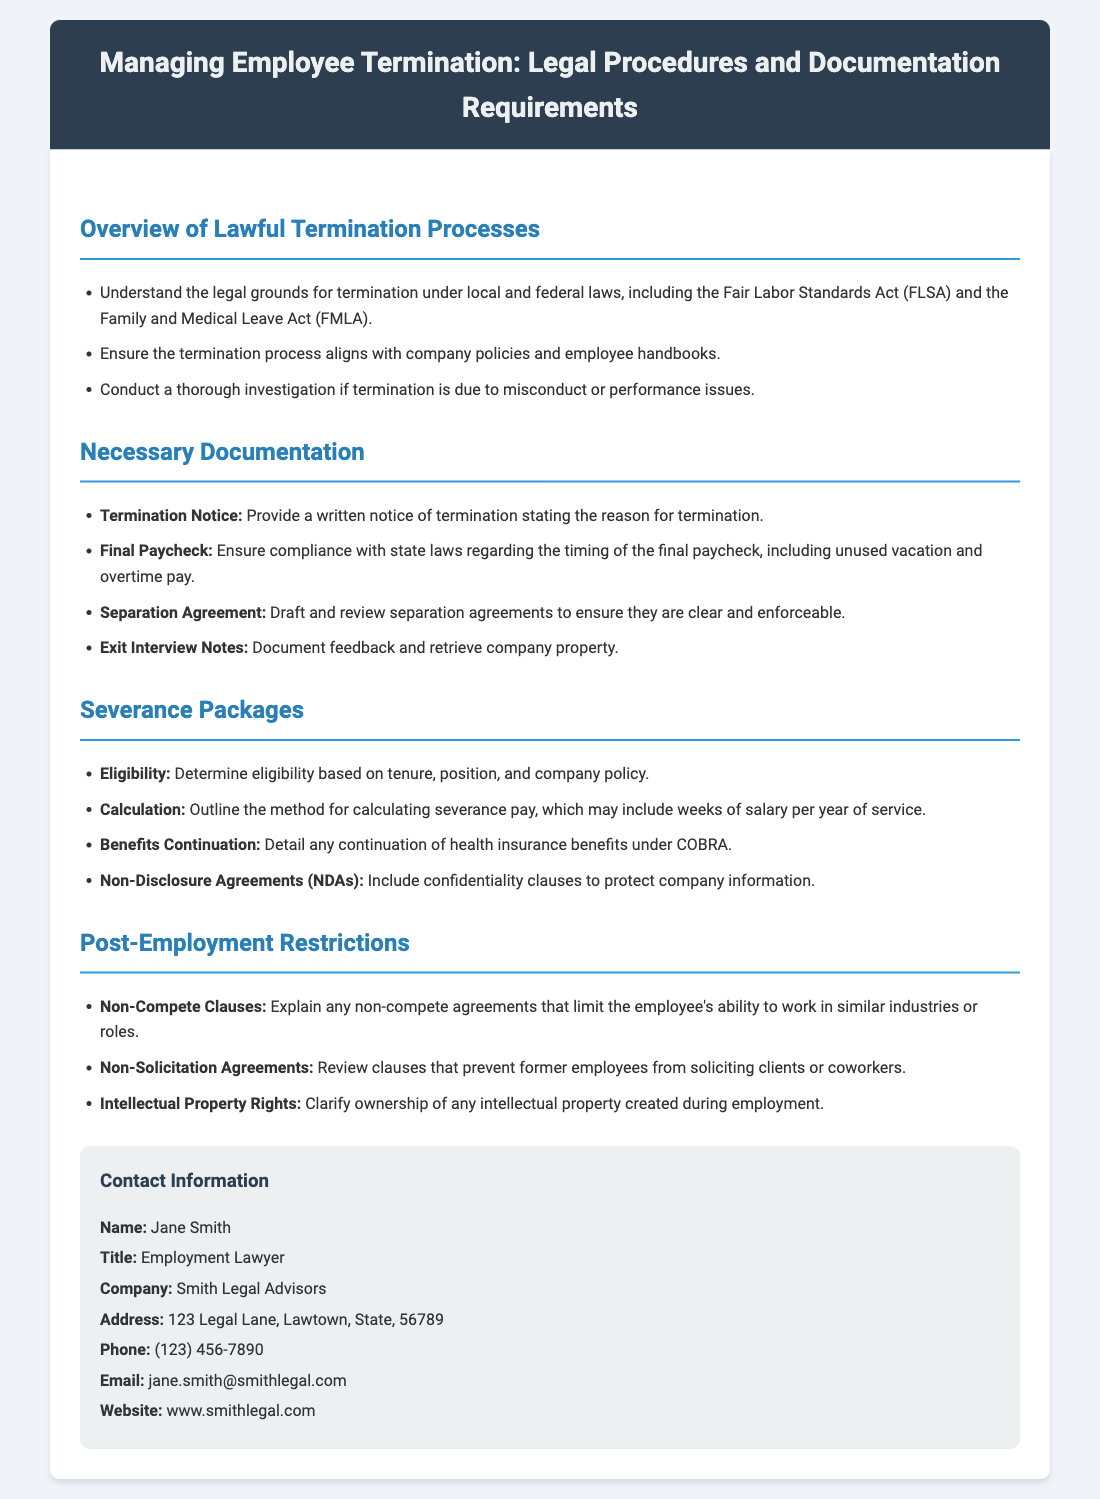what is the title of the document? The title is displayed prominently at the top of the document.
Answer: Managing Employee Termination: Legal Procedures and Documentation Requirements who is the contact person in the document? The document provides contact information for a specific individual.
Answer: Jane Smith what should a termination notice include? The document outlines what to include in a termination notice.
Answer: Reason for termination what is one type of post-employment restriction mentioned? The document lists different types of post-employment restrictions related to former employees.
Answer: Non-Compete Clauses how is severance pay typically calculated according to the document? The document specifies how to determine severance pay based on employee tenure.
Answer: Weeks of salary per year of service what law should the termination process align with? The document references specific laws that must be considered during the termination process.
Answer: Company policies what elements are necessary for a Separation Agreement? The document states that Separation Agreements need to be drafted and reviewed for specific characteristics.
Answer: Clear and enforceable what is required to ensure the timing of the final paycheck? The document emphasizes the importance of compliance with particular laws regarding payment.
Answer: State laws how can health insurance benefits be continued after termination? The document mentions a specific act that addresses health benefits continuation for terminated employees.
Answer: COBRA 